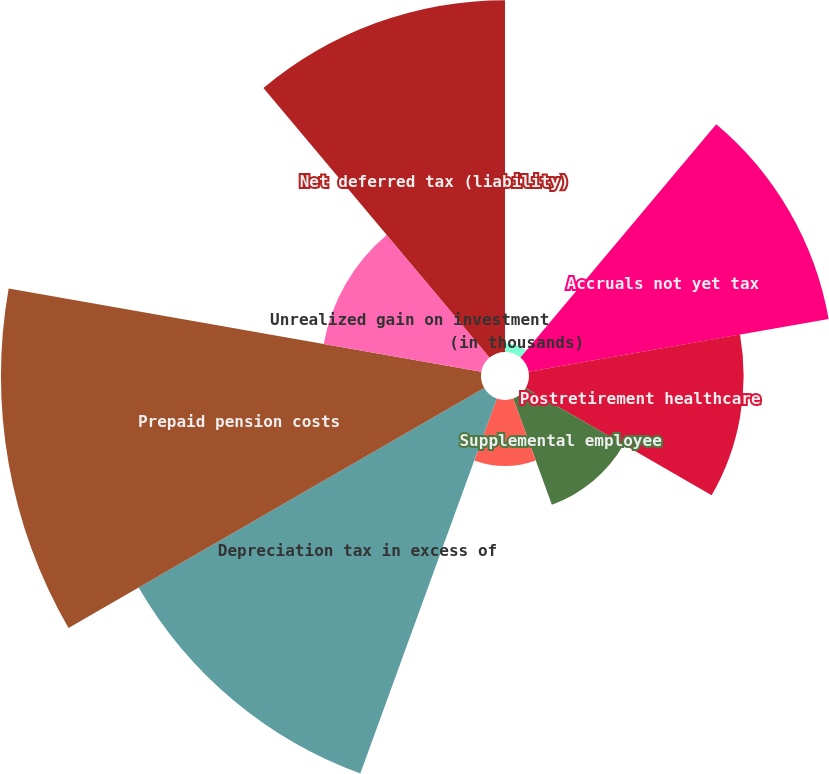<chart> <loc_0><loc_0><loc_500><loc_500><pie_chart><fcel>(in thousands)<fcel>Accruals not yet tax<fcel>Postretirement healthcare<fcel>Supplemental employee<fcel>Other net<fcel>Depreciation tax in excess of<fcel>Prepaid pension costs<fcel>Unrealized gain on investment<fcel>Net deferred tax (liability)<nl><fcel>0.42%<fcel>14.52%<fcel>10.23%<fcel>5.39%<fcel>3.14%<fcel>19.02%<fcel>22.88%<fcel>7.63%<fcel>16.77%<nl></chart> 